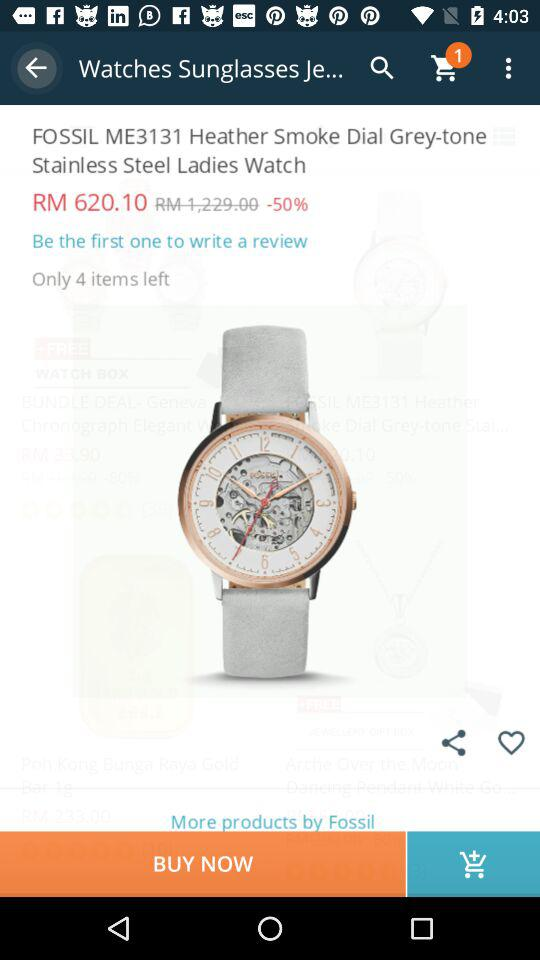How many items are left in stock?
Answer the question using a single word or phrase. 4 